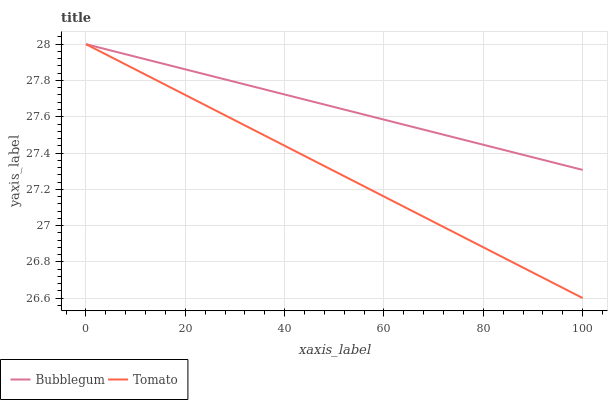Does Tomato have the minimum area under the curve?
Answer yes or no. Yes. Does Bubblegum have the maximum area under the curve?
Answer yes or no. Yes. Does Bubblegum have the minimum area under the curve?
Answer yes or no. No. Is Tomato the smoothest?
Answer yes or no. Yes. Is Bubblegum the roughest?
Answer yes or no. Yes. Is Bubblegum the smoothest?
Answer yes or no. No. Does Tomato have the lowest value?
Answer yes or no. Yes. Does Bubblegum have the lowest value?
Answer yes or no. No. Does Bubblegum have the highest value?
Answer yes or no. Yes. Does Bubblegum intersect Tomato?
Answer yes or no. Yes. Is Bubblegum less than Tomato?
Answer yes or no. No. Is Bubblegum greater than Tomato?
Answer yes or no. No. 